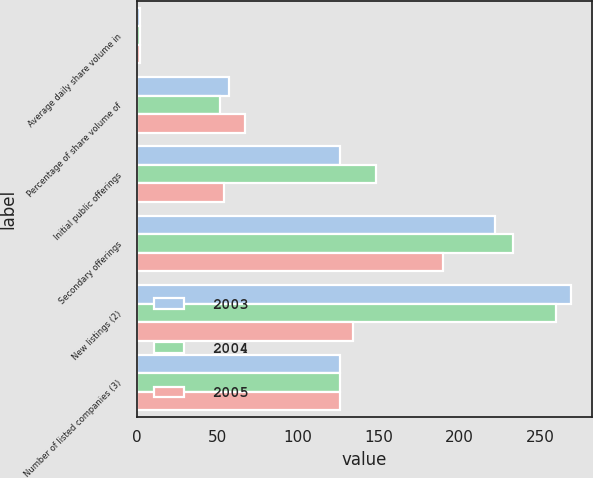Convert chart to OTSL. <chart><loc_0><loc_0><loc_500><loc_500><stacked_bar_chart><ecel><fcel>Average daily share volume in<fcel>Percentage of share volume of<fcel>Initial public offerings<fcel>Secondary offerings<fcel>New listings (2)<fcel>Number of listed companies (3)<nl><fcel>2003<fcel>1.8<fcel>57<fcel>126<fcel>222<fcel>269<fcel>126<nl><fcel>2004<fcel>1.81<fcel>51.3<fcel>148<fcel>233<fcel>260<fcel>126<nl><fcel>2005<fcel>1.69<fcel>67<fcel>54<fcel>190<fcel>134<fcel>126<nl></chart> 